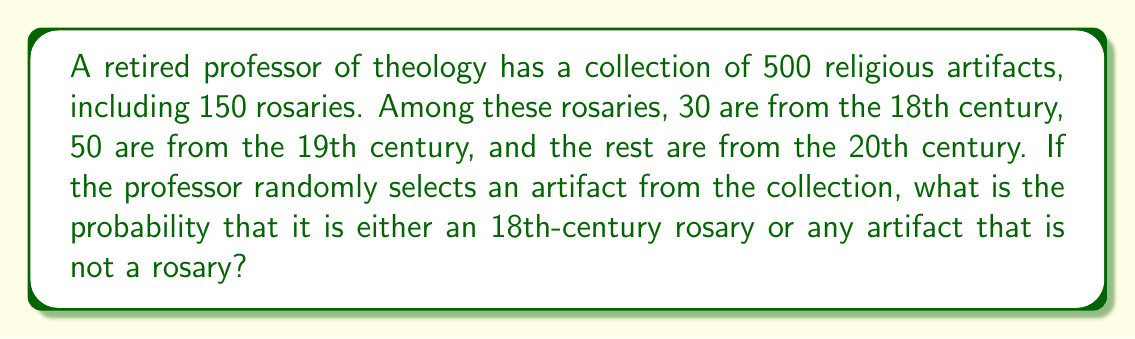Provide a solution to this math problem. Let's approach this step-by-step:

1) First, let's identify the probabilities we need:
   a) Probability of selecting an 18th-century rosary
   b) Probability of selecting any artifact that is not a rosary

2) For the 18th-century rosary:
   - Total artifacts: 500
   - 18th-century rosaries: 30
   - Probability = $\frac{30}{500} = \frac{3}{50} = 0.06$

3) For artifacts that are not rosaries:
   - Total artifacts: 500
   - Total rosaries: 150
   - Non-rosary artifacts: 500 - 150 = 350
   - Probability = $\frac{350}{500} = \frac{7}{10} = 0.7$

4) The question asks for the probability of selecting either an 18th-century rosary OR any non-rosary artifact. This is a case of mutually exclusive events, so we can add the probabilities:

   $P(\text{18th-century rosary or non-rosary}) = P(\text{18th-century rosary}) + P(\text{non-rosary})$

   $= \frac{3}{50} + \frac{7}{10}$

5) To add these fractions, we need a common denominator:
   $\frac{3}{50} + \frac{7}{10} = \frac{3}{50} + \frac{35}{50} = \frac{38}{50} = \frac{19}{25} = 0.76$

Therefore, the probability of selecting either an 18th-century rosary or any artifact that is not a rosary is $\frac{19}{25}$ or 0.76 or 76%.
Answer: $\frac{19}{25}$ 